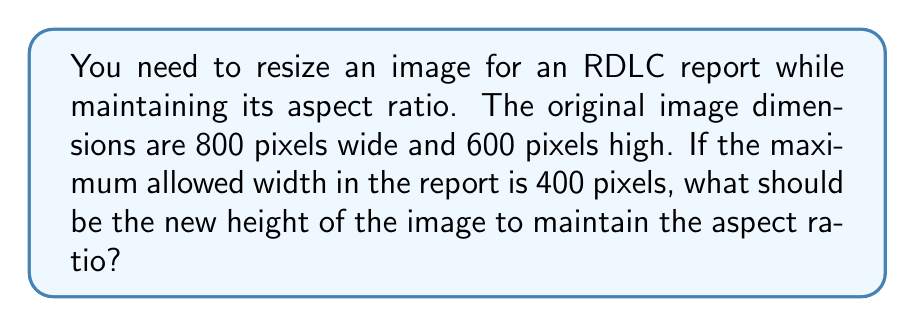Could you help me with this problem? To maintain the aspect ratio while resizing an image, we need to calculate the scale factor and apply it to both dimensions. Let's approach this step-by-step:

1. Calculate the scale factor:
   Scale factor = New width / Original width
   $$ \text{Scale factor} = \frac{\text{New width}}{\text{Original width}} = \frac{400}{800} = 0.5 $$

2. The scale factor is 0.5, which means we need to reduce both dimensions by half to maintain the aspect ratio.

3. Calculate the new height:
   New height = Original height × Scale factor
   $$ \text{New height} = 600 \times 0.5 = 300 \text{ pixels} $$

4. Verify the aspect ratio:
   Original aspect ratio: $\frac{800}{600} = \frac{4}{3}$
   New aspect ratio: $\frac{400}{300} = \frac{4}{3}$

The new dimensions (400x300) maintain the same aspect ratio as the original image (800x600).
Answer: The new height of the image should be 300 pixels. 